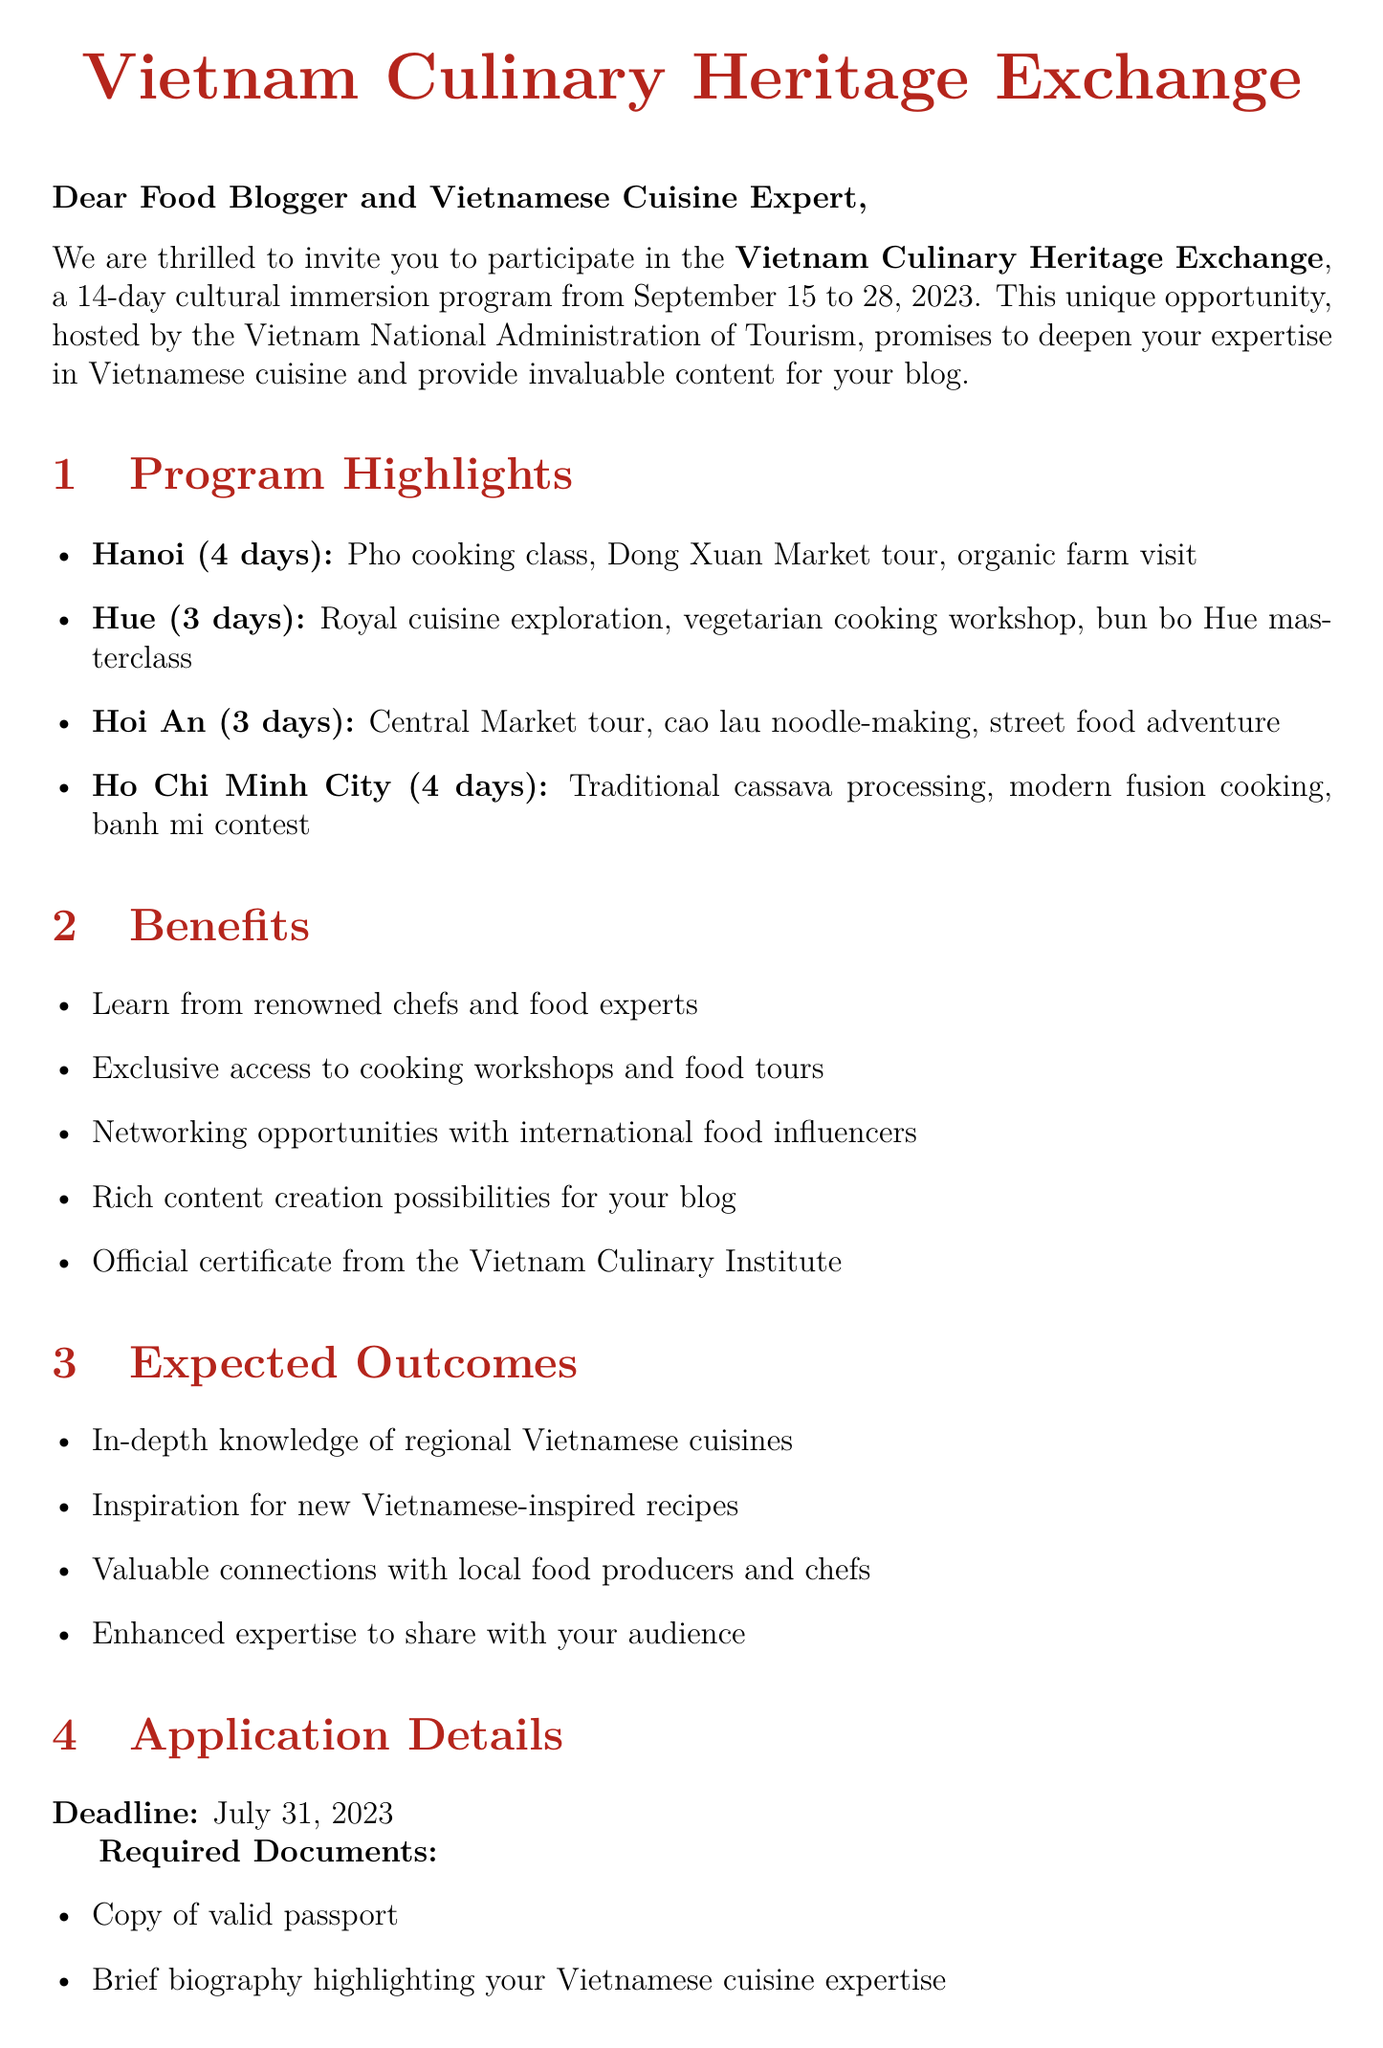What is the name of the program? The program name is explicitly stated in the document.
Answer: Vietnam Culinary Heritage Exchange Who is hosting the program? The document specifies the organization responsible for hosting the program.
Answer: Vietnam National Administration of Tourism How long is the duration of the program? The duration is clearly mentioned in the document.
Answer: 14 days What is the starting date of the program? The starting date is provided in the document.
Answer: September 15, 2023 What activities will participants engage in while in Hanoi? The document lists activities designated for each region, including Hanoi.
Answer: Pho cooking class, Dong Xuan Market tour, organic farm visit What is one benefit of participating in the program? The document outlines several participant benefits.
Answer: Opportunity to learn from renowned Vietnamese chefs and food experts What is required to apply for the program? The document details the necessary documents for application.
Answer: Copy of valid passport What is the application deadline? The deadline for submitting applications is specified in the document.
Answer: July 31, 2023 Who should participants contact for more information? The contact person is named in the document for further inquiries.
Answer: Ms. Tran Thi Lan Anh 